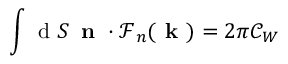<formula> <loc_0><loc_0><loc_500><loc_500>\int d S \, n \cdot \mathcal { F } _ { n } ( k ) = 2 \pi \mathcal { C } _ { W }</formula> 